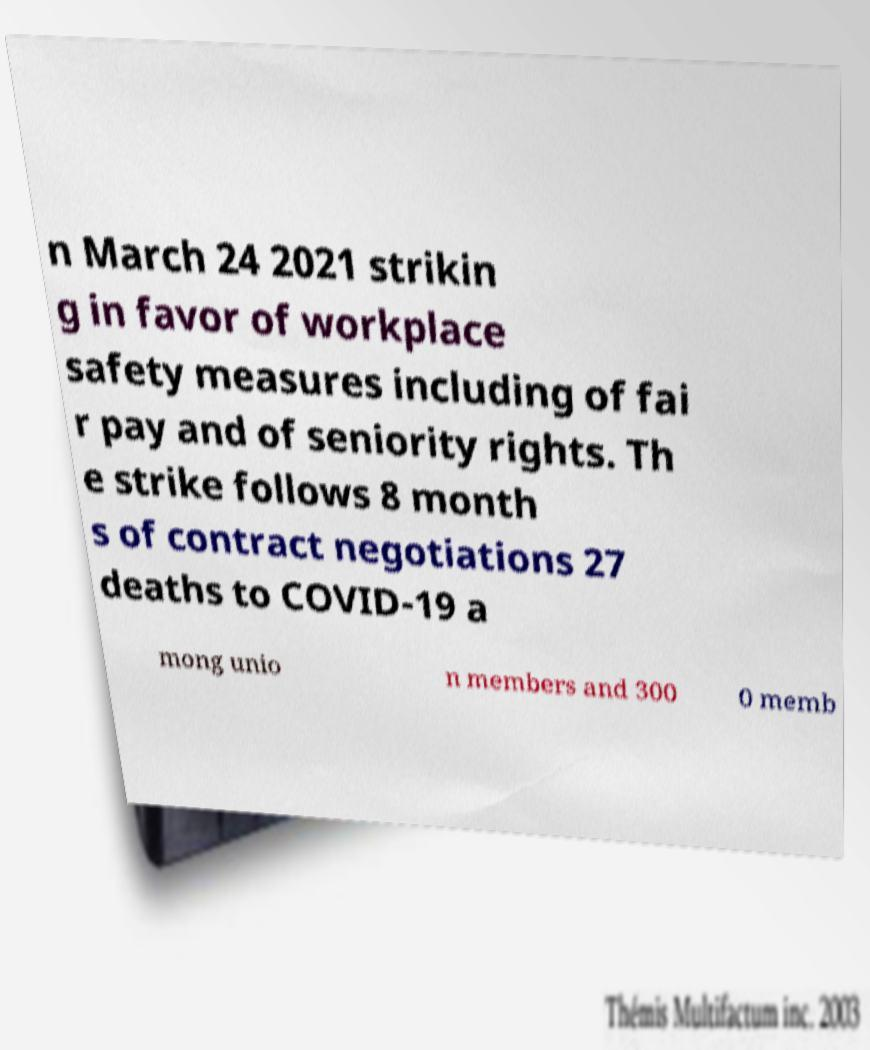Could you assist in decoding the text presented in this image and type it out clearly? n March 24 2021 strikin g in favor of workplace safety measures including of fai r pay and of seniority rights. Th e strike follows 8 month s of contract negotiations 27 deaths to COVID-19 a mong unio n members and 300 0 memb 